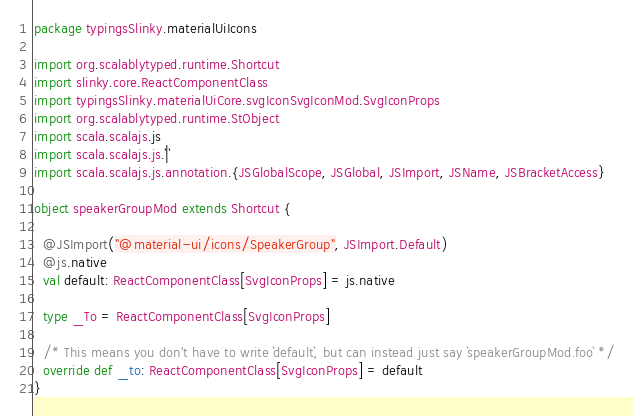<code> <loc_0><loc_0><loc_500><loc_500><_Scala_>package typingsSlinky.materialUiIcons

import org.scalablytyped.runtime.Shortcut
import slinky.core.ReactComponentClass
import typingsSlinky.materialUiCore.svgIconSvgIconMod.SvgIconProps
import org.scalablytyped.runtime.StObject
import scala.scalajs.js
import scala.scalajs.js.`|`
import scala.scalajs.js.annotation.{JSGlobalScope, JSGlobal, JSImport, JSName, JSBracketAccess}

object speakerGroupMod extends Shortcut {
  
  @JSImport("@material-ui/icons/SpeakerGroup", JSImport.Default)
  @js.native
  val default: ReactComponentClass[SvgIconProps] = js.native
  
  type _To = ReactComponentClass[SvgIconProps]
  
  /* This means you don't have to write `default`, but can instead just say `speakerGroupMod.foo` */
  override def _to: ReactComponentClass[SvgIconProps] = default
}
</code> 